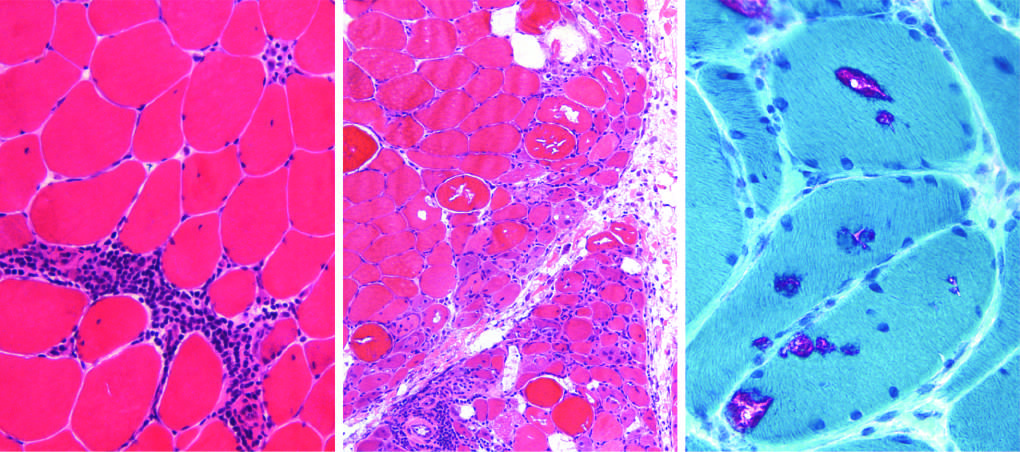what is polymyositis characterized by?
Answer the question using a single word or phrase. Endomysial inflammatory infiltrates and myofiber necrosis 